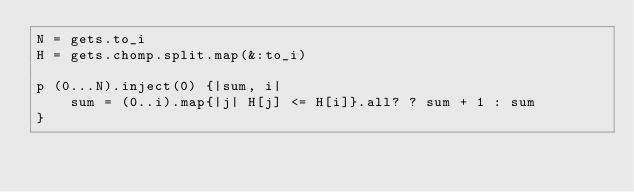<code> <loc_0><loc_0><loc_500><loc_500><_Ruby_>N = gets.to_i
H = gets.chomp.split.map(&:to_i)

p (0...N).inject(0) {|sum, i|
    sum = (0..i).map{|j| H[j] <= H[i]}.all? ? sum + 1 : sum
}</code> 